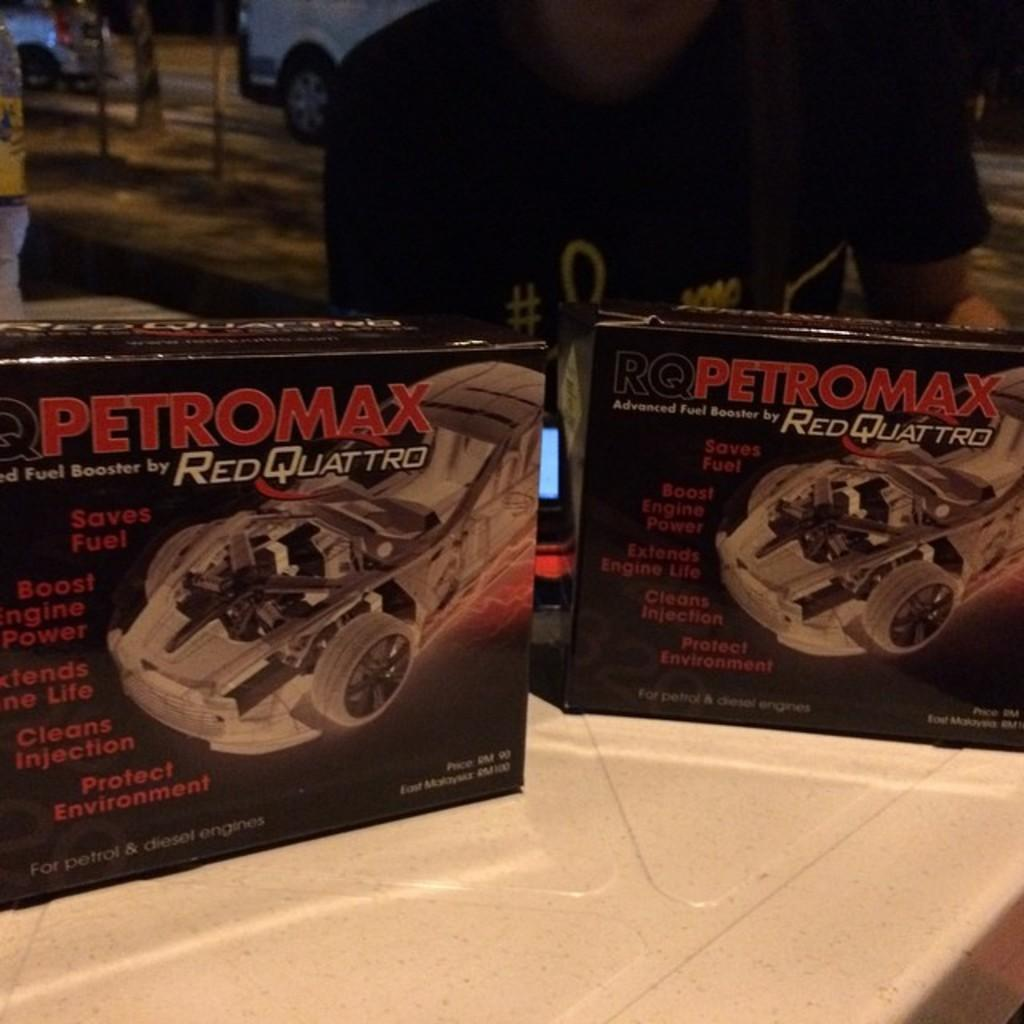What objects are present in the image? There are two black boxes in the image. Where are the black boxes located? The boxes are on a surface. Can you describe the background of the image? There is a person in the background of the image, and there are vehicles parked on the road. What type of game is being played on the patch of grass in the image? There is no patch of grass or game present in the image; it features two black boxes on a surface and a background with a person and parked vehicles. 